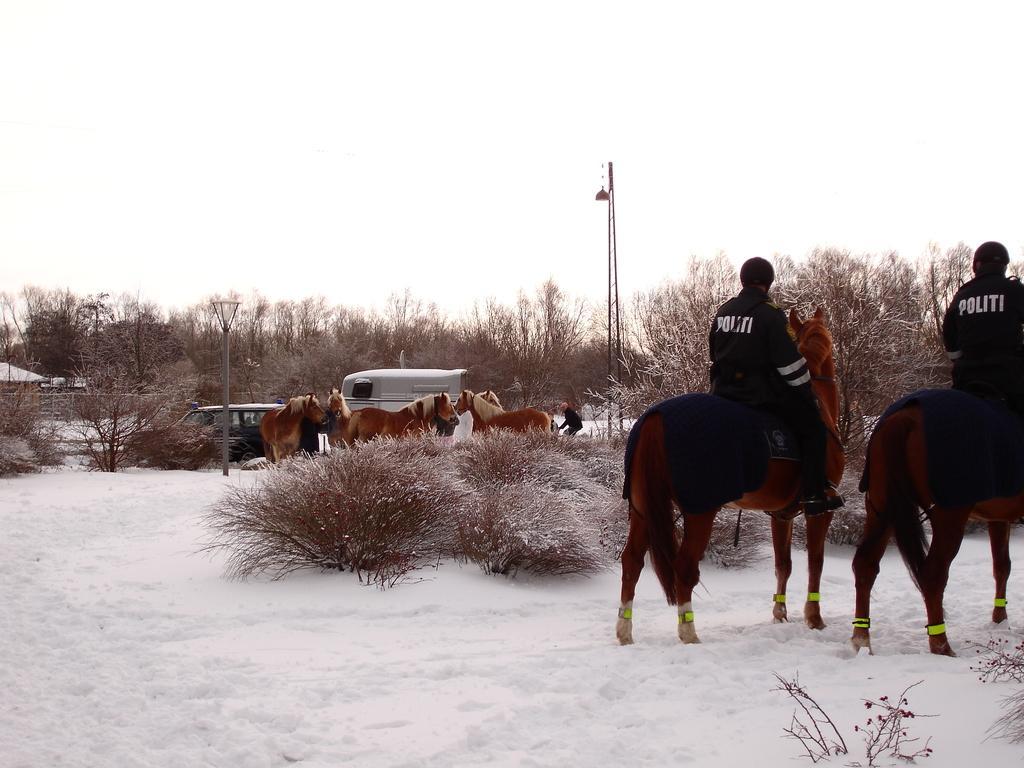Please provide a concise description of this image. This is an outside view. At the bottom, I can see the snow and many plants. On the right side there are two persons wearing jackets and sitting on the horses. In the background there are some more horses, vehicles and light poles. In the background there are many trees. On the left side there is a house. At the top of the image I can see the sky. 